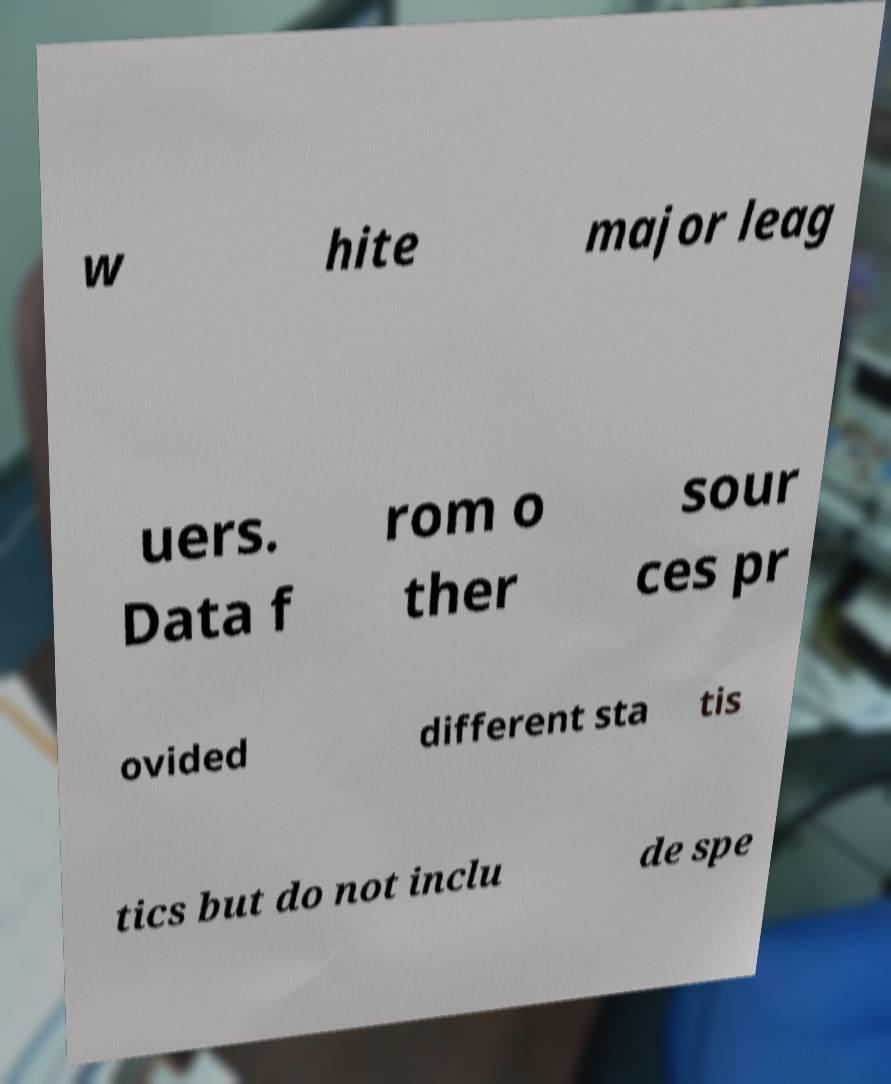There's text embedded in this image that I need extracted. Can you transcribe it verbatim? w hite major leag uers. Data f rom o ther sour ces pr ovided different sta tis tics but do not inclu de spe 